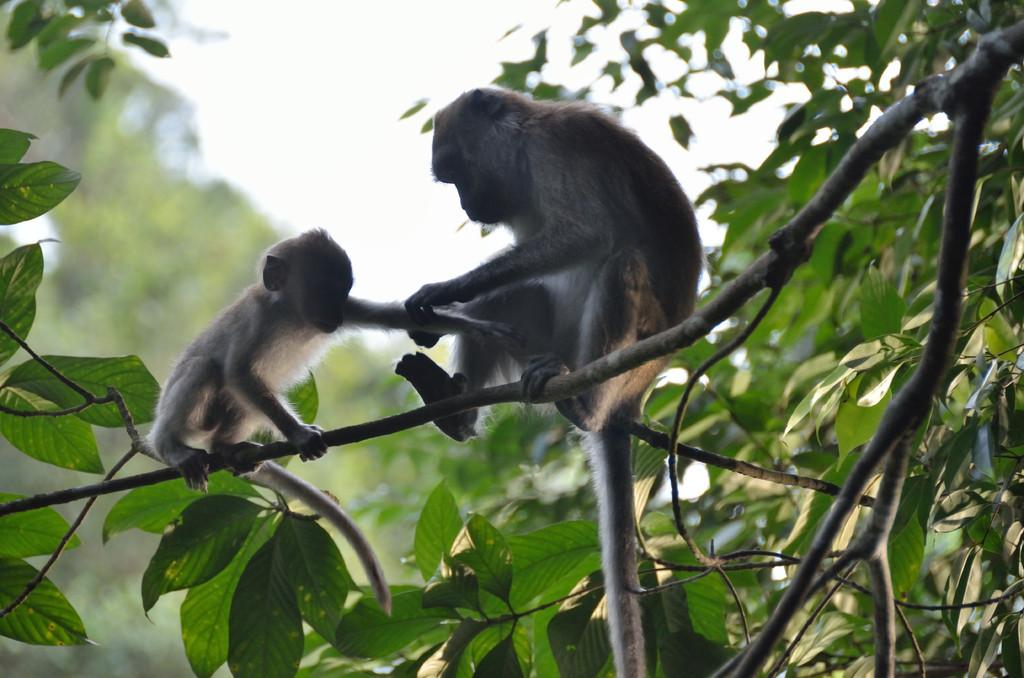How many monkeys are in the image? There are two monkeys in the image. Where are the monkeys located? The monkeys are on a branch of a tree. What else can be seen in the image besides the monkeys? There are other trees in the background of the image. What is visible in the sky in the background of the image? There are clouds in the sky in the background of the image. What type of quiver can be seen in the image? There is no quiver present in the image. How does the fire affect the monkeys in the image? There is no fire present in the image; the monkeys are on a branch of a tree. 